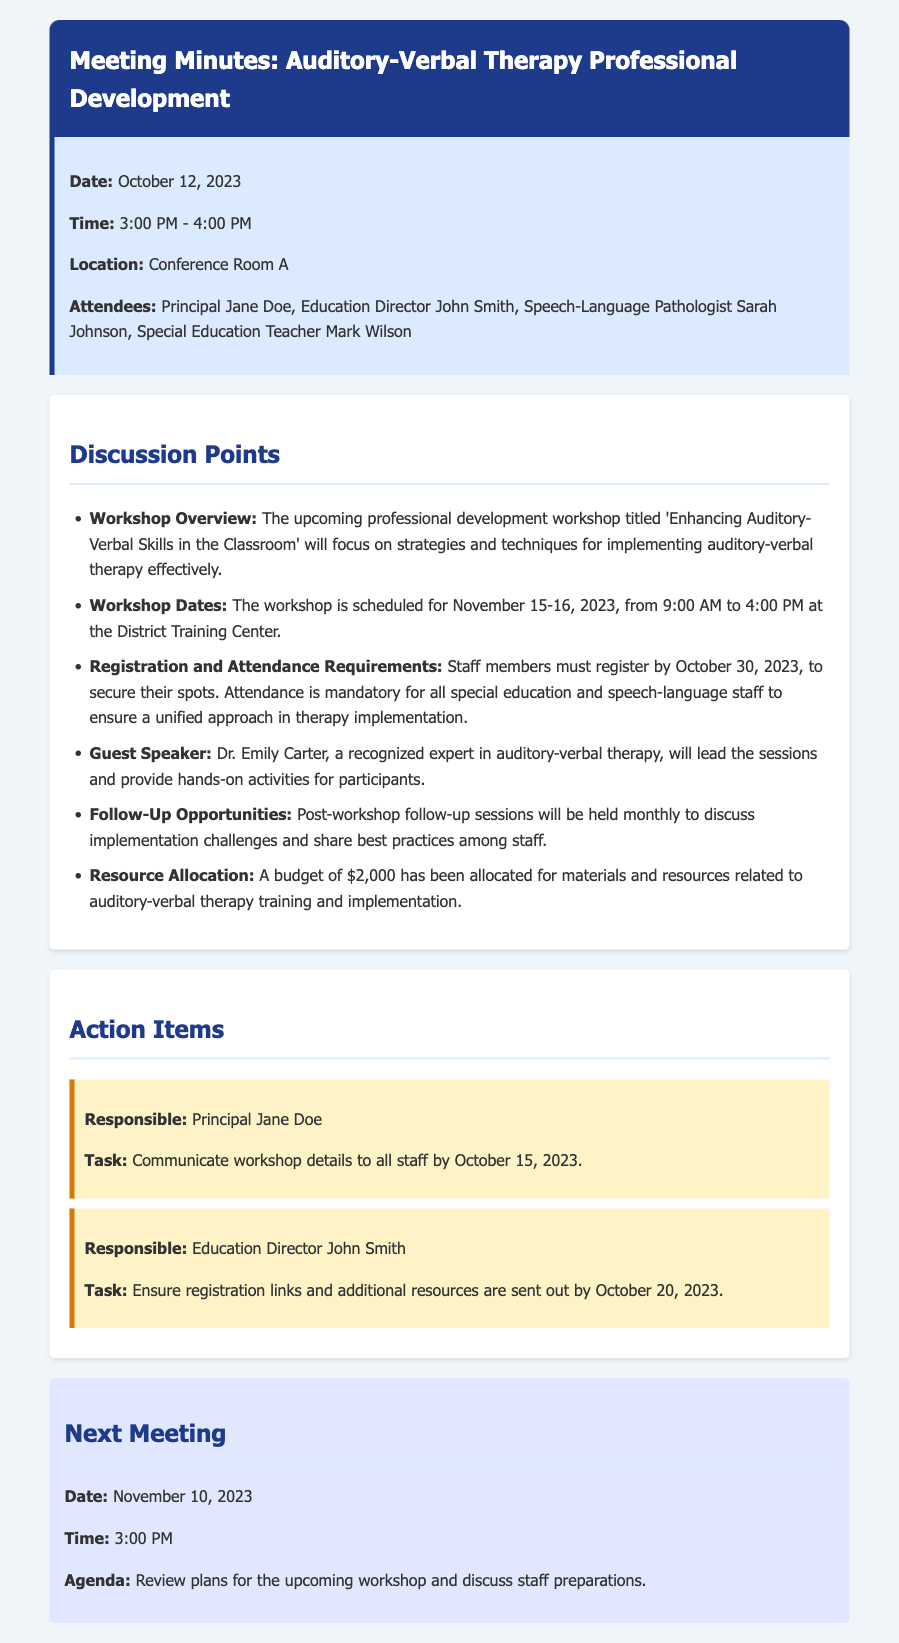what is the date of the workshop? The workshop is scheduled for November 15-16, 2023, as mentioned in the document.
Answer: November 15-16, 2023 who is the guest speaker for the workshop? The document states that Dr. Emily Carter will lead the sessions at the workshop.
Answer: Dr. Emily Carter what is the deadline for staff registration? The document specifies that staff must register by October 30, 2023.
Answer: October 30, 2023 how much budget has been allocated for training? According to the document, a budget of $2,000 has been allocated for the training and implementation.
Answer: $2,000 what is mandatory for special education and speech-language staff? The document indicates that attendance is mandatory for these staff members to ensure a unified approach.
Answer: Attendance which room is the meeting taking place in? The location of the meeting mentioned in the document is Conference Room A.
Answer: Conference Room A what is the next meeting date? The document states that the next meeting is scheduled for November 10, 2023.
Answer: November 10, 2023 who is responsible for communicating workshop details? The document lists Principal Jane Doe as responsible for this task.
Answer: Principal Jane Doe what time will the workshop start each day? The document specifies that the workshop will start at 9:00 AM each day.
Answer: 9:00 AM 